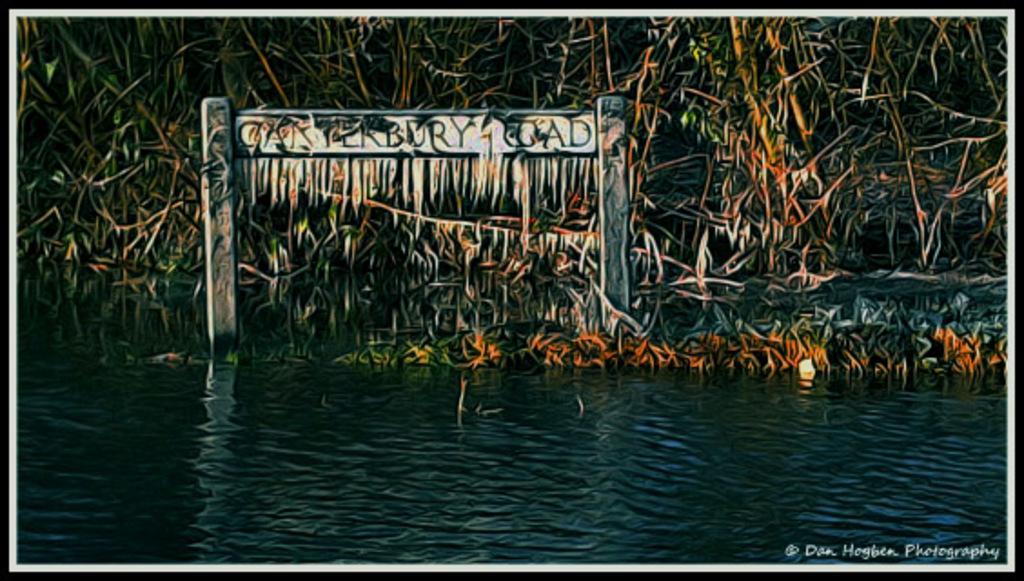Can you describe this image briefly? This picture shows an edited image and we see water and few trees and a name board and we see a watermark on the right bottom of the picture. 